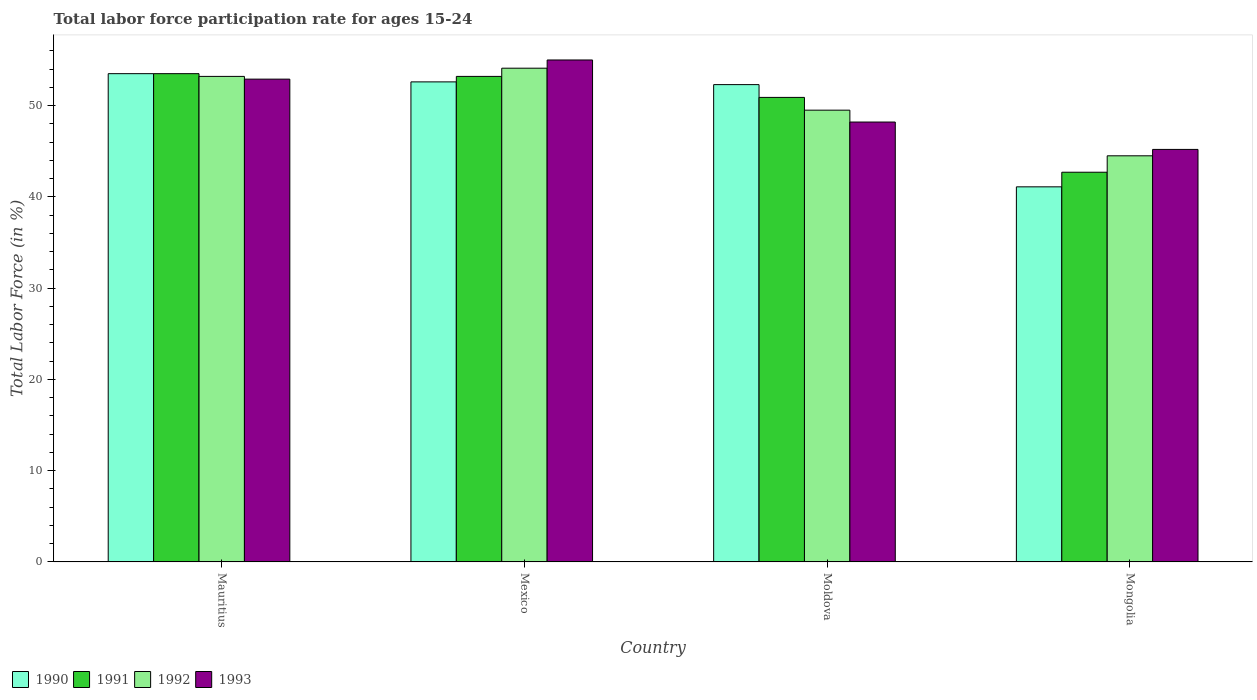How many different coloured bars are there?
Keep it short and to the point. 4. How many groups of bars are there?
Ensure brevity in your answer.  4. Are the number of bars on each tick of the X-axis equal?
Your response must be concise. Yes. How many bars are there on the 4th tick from the right?
Provide a succinct answer. 4. What is the label of the 1st group of bars from the left?
Your answer should be compact. Mauritius. In how many cases, is the number of bars for a given country not equal to the number of legend labels?
Your response must be concise. 0. What is the labor force participation rate in 1990 in Mexico?
Give a very brief answer. 52.6. Across all countries, what is the maximum labor force participation rate in 1990?
Keep it short and to the point. 53.5. Across all countries, what is the minimum labor force participation rate in 1990?
Your response must be concise. 41.1. In which country was the labor force participation rate in 1990 maximum?
Provide a short and direct response. Mauritius. In which country was the labor force participation rate in 1992 minimum?
Your answer should be very brief. Mongolia. What is the total labor force participation rate in 1993 in the graph?
Your response must be concise. 201.3. What is the difference between the labor force participation rate in 1991 in Moldova and the labor force participation rate in 1992 in Mauritius?
Keep it short and to the point. -2.3. What is the average labor force participation rate in 1992 per country?
Your response must be concise. 50.32. What is the difference between the labor force participation rate of/in 1993 and labor force participation rate of/in 1992 in Mexico?
Your answer should be very brief. 0.9. In how many countries, is the labor force participation rate in 1990 greater than 16 %?
Keep it short and to the point. 4. What is the ratio of the labor force participation rate in 1992 in Mauritius to that in Mexico?
Ensure brevity in your answer.  0.98. Is the labor force participation rate in 1991 in Mauritius less than that in Mexico?
Provide a short and direct response. No. Is the difference between the labor force participation rate in 1993 in Moldova and Mongolia greater than the difference between the labor force participation rate in 1992 in Moldova and Mongolia?
Your answer should be very brief. No. What is the difference between the highest and the second highest labor force participation rate in 1993?
Your response must be concise. -4.7. What is the difference between the highest and the lowest labor force participation rate in 1993?
Keep it short and to the point. 9.8. What does the 2nd bar from the right in Mexico represents?
Offer a very short reply. 1992. Is it the case that in every country, the sum of the labor force participation rate in 1991 and labor force participation rate in 1992 is greater than the labor force participation rate in 1993?
Provide a succinct answer. Yes. How many countries are there in the graph?
Ensure brevity in your answer.  4. Where does the legend appear in the graph?
Your response must be concise. Bottom left. How many legend labels are there?
Your answer should be compact. 4. What is the title of the graph?
Offer a terse response. Total labor force participation rate for ages 15-24. Does "1981" appear as one of the legend labels in the graph?
Your answer should be very brief. No. What is the label or title of the X-axis?
Give a very brief answer. Country. What is the Total Labor Force (in %) of 1990 in Mauritius?
Your answer should be very brief. 53.5. What is the Total Labor Force (in %) in 1991 in Mauritius?
Offer a very short reply. 53.5. What is the Total Labor Force (in %) of 1992 in Mauritius?
Keep it short and to the point. 53.2. What is the Total Labor Force (in %) in 1993 in Mauritius?
Offer a very short reply. 52.9. What is the Total Labor Force (in %) of 1990 in Mexico?
Make the answer very short. 52.6. What is the Total Labor Force (in %) of 1991 in Mexico?
Your response must be concise. 53.2. What is the Total Labor Force (in %) of 1992 in Mexico?
Provide a short and direct response. 54.1. What is the Total Labor Force (in %) of 1993 in Mexico?
Your answer should be very brief. 55. What is the Total Labor Force (in %) of 1990 in Moldova?
Offer a very short reply. 52.3. What is the Total Labor Force (in %) of 1991 in Moldova?
Keep it short and to the point. 50.9. What is the Total Labor Force (in %) of 1992 in Moldova?
Offer a terse response. 49.5. What is the Total Labor Force (in %) in 1993 in Moldova?
Offer a terse response. 48.2. What is the Total Labor Force (in %) of 1990 in Mongolia?
Your response must be concise. 41.1. What is the Total Labor Force (in %) in 1991 in Mongolia?
Your answer should be very brief. 42.7. What is the Total Labor Force (in %) in 1992 in Mongolia?
Offer a very short reply. 44.5. What is the Total Labor Force (in %) of 1993 in Mongolia?
Provide a succinct answer. 45.2. Across all countries, what is the maximum Total Labor Force (in %) in 1990?
Provide a short and direct response. 53.5. Across all countries, what is the maximum Total Labor Force (in %) in 1991?
Make the answer very short. 53.5. Across all countries, what is the maximum Total Labor Force (in %) in 1992?
Give a very brief answer. 54.1. Across all countries, what is the maximum Total Labor Force (in %) in 1993?
Your answer should be very brief. 55. Across all countries, what is the minimum Total Labor Force (in %) in 1990?
Your answer should be compact. 41.1. Across all countries, what is the minimum Total Labor Force (in %) in 1991?
Keep it short and to the point. 42.7. Across all countries, what is the minimum Total Labor Force (in %) of 1992?
Provide a short and direct response. 44.5. Across all countries, what is the minimum Total Labor Force (in %) of 1993?
Provide a short and direct response. 45.2. What is the total Total Labor Force (in %) in 1990 in the graph?
Make the answer very short. 199.5. What is the total Total Labor Force (in %) in 1991 in the graph?
Keep it short and to the point. 200.3. What is the total Total Labor Force (in %) in 1992 in the graph?
Your answer should be compact. 201.3. What is the total Total Labor Force (in %) of 1993 in the graph?
Your answer should be very brief. 201.3. What is the difference between the Total Labor Force (in %) of 1990 in Mauritius and that in Mexico?
Provide a succinct answer. 0.9. What is the difference between the Total Labor Force (in %) of 1991 in Mauritius and that in Mexico?
Give a very brief answer. 0.3. What is the difference between the Total Labor Force (in %) in 1992 in Mauritius and that in Mexico?
Keep it short and to the point. -0.9. What is the difference between the Total Labor Force (in %) of 1993 in Mauritius and that in Mexico?
Make the answer very short. -2.1. What is the difference between the Total Labor Force (in %) in 1991 in Mauritius and that in Moldova?
Keep it short and to the point. 2.6. What is the difference between the Total Labor Force (in %) of 1992 in Mauritius and that in Moldova?
Make the answer very short. 3.7. What is the difference between the Total Labor Force (in %) of 1991 in Mauritius and that in Mongolia?
Ensure brevity in your answer.  10.8. What is the difference between the Total Labor Force (in %) in 1992 in Mauritius and that in Mongolia?
Give a very brief answer. 8.7. What is the difference between the Total Labor Force (in %) of 1992 in Mexico and that in Moldova?
Keep it short and to the point. 4.6. What is the difference between the Total Labor Force (in %) of 1993 in Mexico and that in Moldova?
Provide a succinct answer. 6.8. What is the difference between the Total Labor Force (in %) in 1990 in Mexico and that in Mongolia?
Offer a very short reply. 11.5. What is the difference between the Total Labor Force (in %) of 1991 in Mexico and that in Mongolia?
Offer a very short reply. 10.5. What is the difference between the Total Labor Force (in %) of 1993 in Mexico and that in Mongolia?
Provide a short and direct response. 9.8. What is the difference between the Total Labor Force (in %) in 1990 in Moldova and that in Mongolia?
Your response must be concise. 11.2. What is the difference between the Total Labor Force (in %) in 1991 in Moldova and that in Mongolia?
Your answer should be compact. 8.2. What is the difference between the Total Labor Force (in %) in 1993 in Moldova and that in Mongolia?
Your answer should be compact. 3. What is the difference between the Total Labor Force (in %) in 1990 in Mauritius and the Total Labor Force (in %) in 1991 in Mexico?
Offer a terse response. 0.3. What is the difference between the Total Labor Force (in %) of 1991 in Mauritius and the Total Labor Force (in %) of 1992 in Mexico?
Your response must be concise. -0.6. What is the difference between the Total Labor Force (in %) in 1990 in Mauritius and the Total Labor Force (in %) in 1992 in Moldova?
Keep it short and to the point. 4. What is the difference between the Total Labor Force (in %) of 1991 in Mauritius and the Total Labor Force (in %) of 1992 in Moldova?
Offer a terse response. 4. What is the difference between the Total Labor Force (in %) of 1991 in Mauritius and the Total Labor Force (in %) of 1993 in Moldova?
Provide a short and direct response. 5.3. What is the difference between the Total Labor Force (in %) of 1990 in Mauritius and the Total Labor Force (in %) of 1991 in Mongolia?
Your response must be concise. 10.8. What is the difference between the Total Labor Force (in %) in 1990 in Mauritius and the Total Labor Force (in %) in 1992 in Mongolia?
Your response must be concise. 9. What is the difference between the Total Labor Force (in %) of 1991 in Mauritius and the Total Labor Force (in %) of 1992 in Mongolia?
Offer a terse response. 9. What is the difference between the Total Labor Force (in %) of 1992 in Mauritius and the Total Labor Force (in %) of 1993 in Mongolia?
Give a very brief answer. 8. What is the difference between the Total Labor Force (in %) in 1990 in Mexico and the Total Labor Force (in %) in 1993 in Moldova?
Offer a very short reply. 4.4. What is the difference between the Total Labor Force (in %) in 1990 in Mexico and the Total Labor Force (in %) in 1992 in Mongolia?
Your answer should be compact. 8.1. What is the difference between the Total Labor Force (in %) in 1990 in Moldova and the Total Labor Force (in %) in 1991 in Mongolia?
Your answer should be very brief. 9.6. What is the difference between the Total Labor Force (in %) in 1991 in Moldova and the Total Labor Force (in %) in 1992 in Mongolia?
Your answer should be very brief. 6.4. What is the average Total Labor Force (in %) of 1990 per country?
Provide a succinct answer. 49.88. What is the average Total Labor Force (in %) in 1991 per country?
Offer a terse response. 50.08. What is the average Total Labor Force (in %) of 1992 per country?
Your answer should be very brief. 50.33. What is the average Total Labor Force (in %) of 1993 per country?
Make the answer very short. 50.33. What is the difference between the Total Labor Force (in %) of 1990 and Total Labor Force (in %) of 1991 in Mauritius?
Keep it short and to the point. 0. What is the difference between the Total Labor Force (in %) of 1990 and Total Labor Force (in %) of 1992 in Mauritius?
Provide a succinct answer. 0.3. What is the difference between the Total Labor Force (in %) in 1991 and Total Labor Force (in %) in 1993 in Mauritius?
Provide a short and direct response. 0.6. What is the difference between the Total Labor Force (in %) of 1990 and Total Labor Force (in %) of 1991 in Mexico?
Your answer should be very brief. -0.6. What is the difference between the Total Labor Force (in %) of 1990 and Total Labor Force (in %) of 1993 in Mexico?
Offer a terse response. -2.4. What is the difference between the Total Labor Force (in %) in 1991 and Total Labor Force (in %) in 1992 in Mexico?
Ensure brevity in your answer.  -0.9. What is the difference between the Total Labor Force (in %) of 1990 and Total Labor Force (in %) of 1992 in Moldova?
Your answer should be compact. 2.8. What is the difference between the Total Labor Force (in %) in 1990 and Total Labor Force (in %) in 1993 in Moldova?
Provide a succinct answer. 4.1. What is the difference between the Total Labor Force (in %) in 1991 and Total Labor Force (in %) in 1993 in Moldova?
Ensure brevity in your answer.  2.7. What is the difference between the Total Labor Force (in %) in 1992 and Total Labor Force (in %) in 1993 in Moldova?
Make the answer very short. 1.3. What is the difference between the Total Labor Force (in %) in 1990 and Total Labor Force (in %) in 1991 in Mongolia?
Provide a short and direct response. -1.6. What is the difference between the Total Labor Force (in %) in 1990 and Total Labor Force (in %) in 1992 in Mongolia?
Your answer should be very brief. -3.4. What is the difference between the Total Labor Force (in %) of 1990 and Total Labor Force (in %) of 1993 in Mongolia?
Provide a succinct answer. -4.1. What is the difference between the Total Labor Force (in %) in 1991 and Total Labor Force (in %) in 1992 in Mongolia?
Keep it short and to the point. -1.8. What is the difference between the Total Labor Force (in %) of 1992 and Total Labor Force (in %) of 1993 in Mongolia?
Offer a terse response. -0.7. What is the ratio of the Total Labor Force (in %) in 1990 in Mauritius to that in Mexico?
Make the answer very short. 1.02. What is the ratio of the Total Labor Force (in %) of 1991 in Mauritius to that in Mexico?
Give a very brief answer. 1.01. What is the ratio of the Total Labor Force (in %) in 1992 in Mauritius to that in Mexico?
Ensure brevity in your answer.  0.98. What is the ratio of the Total Labor Force (in %) of 1993 in Mauritius to that in Mexico?
Ensure brevity in your answer.  0.96. What is the ratio of the Total Labor Force (in %) in 1990 in Mauritius to that in Moldova?
Ensure brevity in your answer.  1.02. What is the ratio of the Total Labor Force (in %) of 1991 in Mauritius to that in Moldova?
Offer a very short reply. 1.05. What is the ratio of the Total Labor Force (in %) of 1992 in Mauritius to that in Moldova?
Your answer should be very brief. 1.07. What is the ratio of the Total Labor Force (in %) of 1993 in Mauritius to that in Moldova?
Keep it short and to the point. 1.1. What is the ratio of the Total Labor Force (in %) in 1990 in Mauritius to that in Mongolia?
Make the answer very short. 1.3. What is the ratio of the Total Labor Force (in %) of 1991 in Mauritius to that in Mongolia?
Give a very brief answer. 1.25. What is the ratio of the Total Labor Force (in %) of 1992 in Mauritius to that in Mongolia?
Give a very brief answer. 1.2. What is the ratio of the Total Labor Force (in %) in 1993 in Mauritius to that in Mongolia?
Ensure brevity in your answer.  1.17. What is the ratio of the Total Labor Force (in %) in 1990 in Mexico to that in Moldova?
Provide a short and direct response. 1.01. What is the ratio of the Total Labor Force (in %) of 1991 in Mexico to that in Moldova?
Your answer should be very brief. 1.05. What is the ratio of the Total Labor Force (in %) of 1992 in Mexico to that in Moldova?
Your response must be concise. 1.09. What is the ratio of the Total Labor Force (in %) in 1993 in Mexico to that in Moldova?
Provide a succinct answer. 1.14. What is the ratio of the Total Labor Force (in %) in 1990 in Mexico to that in Mongolia?
Give a very brief answer. 1.28. What is the ratio of the Total Labor Force (in %) of 1991 in Mexico to that in Mongolia?
Your answer should be compact. 1.25. What is the ratio of the Total Labor Force (in %) of 1992 in Mexico to that in Mongolia?
Give a very brief answer. 1.22. What is the ratio of the Total Labor Force (in %) in 1993 in Mexico to that in Mongolia?
Offer a terse response. 1.22. What is the ratio of the Total Labor Force (in %) of 1990 in Moldova to that in Mongolia?
Provide a succinct answer. 1.27. What is the ratio of the Total Labor Force (in %) in 1991 in Moldova to that in Mongolia?
Provide a succinct answer. 1.19. What is the ratio of the Total Labor Force (in %) in 1992 in Moldova to that in Mongolia?
Offer a terse response. 1.11. What is the ratio of the Total Labor Force (in %) of 1993 in Moldova to that in Mongolia?
Your response must be concise. 1.07. What is the difference between the highest and the second highest Total Labor Force (in %) of 1991?
Keep it short and to the point. 0.3. What is the difference between the highest and the lowest Total Labor Force (in %) in 1990?
Your answer should be compact. 12.4. What is the difference between the highest and the lowest Total Labor Force (in %) of 1993?
Provide a succinct answer. 9.8. 